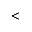<formula> <loc_0><loc_0><loc_500><loc_500><</formula> 